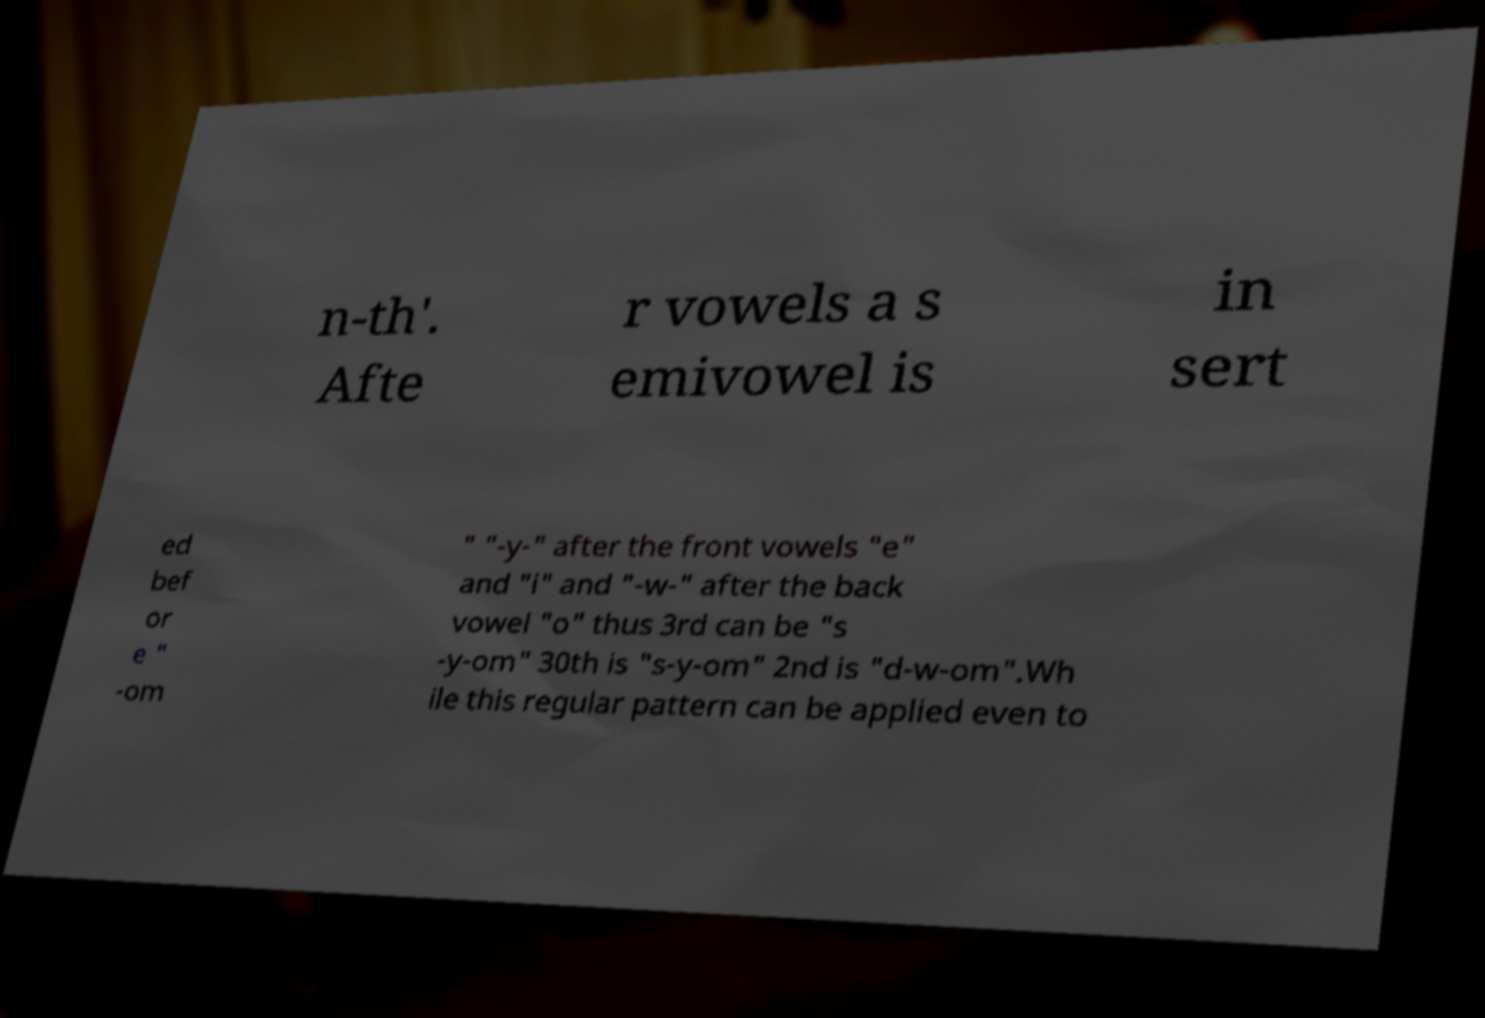Could you assist in decoding the text presented in this image and type it out clearly? n-th'. Afte r vowels a s emivowel is in sert ed bef or e " -om " "-y-" after the front vowels "e" and "i" and "-w-" after the back vowel "o" thus 3rd can be "s -y-om" 30th is "s-y-om" 2nd is "d-w-om".Wh ile this regular pattern can be applied even to 